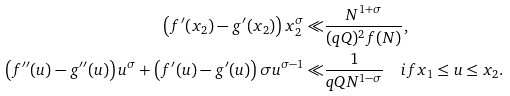<formula> <loc_0><loc_0><loc_500><loc_500>\left ( f ^ { \prime } ( x _ { 2 } ) - g ^ { \prime } ( x _ { 2 } ) \right ) x _ { 2 } ^ { \sigma } \ll & \frac { N ^ { 1 + \sigma } } { ( q Q ) ^ { 2 } f ( N ) } , \\ \left ( f ^ { \prime \prime } ( u ) - g ^ { \prime \prime } ( u ) \right ) u ^ { \sigma } + \left ( f ^ { \prime } ( u ) - g ^ { \prime } ( u ) \right ) \sigma u ^ { \sigma - 1 } \ll & \frac { 1 } { q Q N ^ { 1 - \sigma } } \quad i f x _ { 1 } \leq u \leq x _ { 2 } .</formula> 